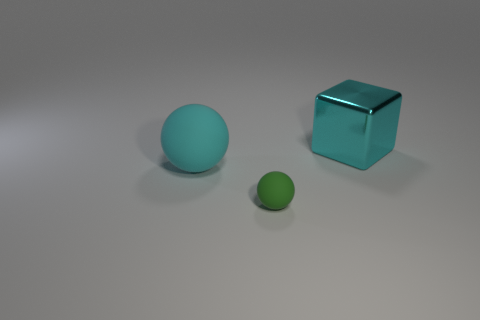Add 2 tiny green matte things. How many objects exist? 5 Subtract all balls. How many objects are left? 1 Add 3 matte objects. How many matte objects are left? 5 Add 3 large brown blocks. How many large brown blocks exist? 3 Subtract 0 blue balls. How many objects are left? 3 Subtract all tiny yellow rubber balls. Subtract all large cyan things. How many objects are left? 1 